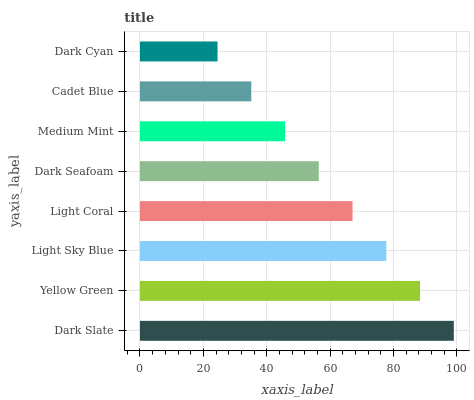Is Dark Cyan the minimum?
Answer yes or no. Yes. Is Dark Slate the maximum?
Answer yes or no. Yes. Is Yellow Green the minimum?
Answer yes or no. No. Is Yellow Green the maximum?
Answer yes or no. No. Is Dark Slate greater than Yellow Green?
Answer yes or no. Yes. Is Yellow Green less than Dark Slate?
Answer yes or no. Yes. Is Yellow Green greater than Dark Slate?
Answer yes or no. No. Is Dark Slate less than Yellow Green?
Answer yes or no. No. Is Light Coral the high median?
Answer yes or no. Yes. Is Dark Seafoam the low median?
Answer yes or no. Yes. Is Cadet Blue the high median?
Answer yes or no. No. Is Light Coral the low median?
Answer yes or no. No. 